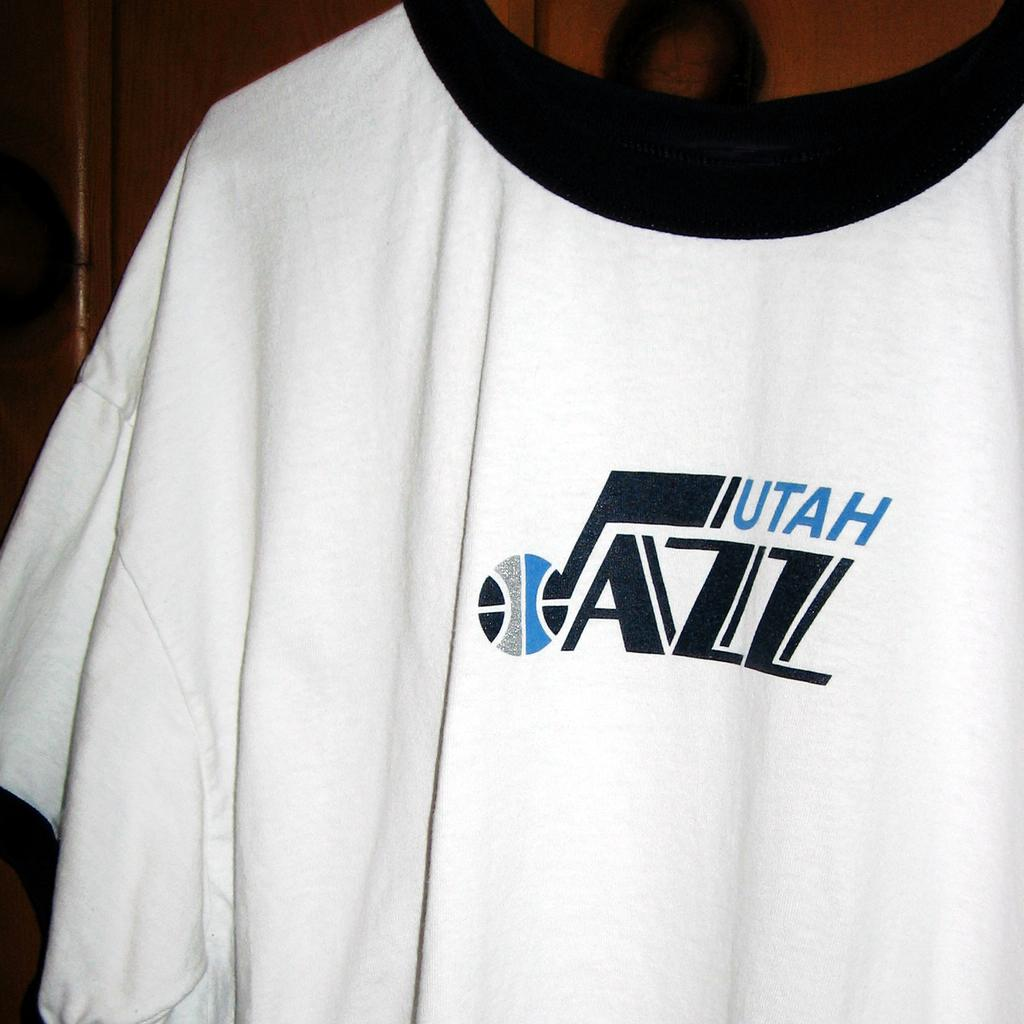<image>
Share a concise interpretation of the image provided. A white tshirt with Utah Jazz on it in black and blue lettering 